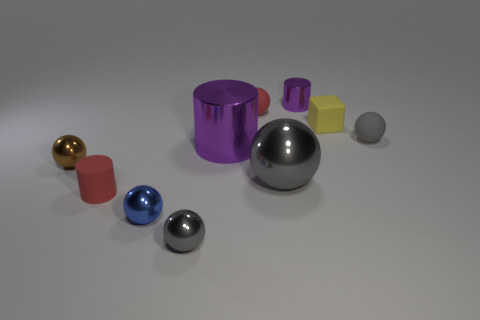There is a thing that is the same color as the tiny shiny cylinder; what is its size?
Your answer should be compact. Large. What is the shape of the rubber thing that is the same color as the large metal ball?
Offer a very short reply. Sphere. How many other large metal objects have the same shape as the big gray object?
Your answer should be very brief. 0. What number of purple things are the same size as the yellow matte cube?
Your response must be concise. 1. There is a red thing that is the same shape as the small purple shiny object; what is it made of?
Ensure brevity in your answer.  Rubber. What is the color of the rubber object that is in front of the brown shiny thing?
Your answer should be compact. Red. Is the number of objects that are in front of the yellow matte thing greater than the number of small purple cylinders?
Your answer should be compact. Yes. The matte block has what color?
Make the answer very short. Yellow. The purple object in front of the red ball that is on the right side of the small metal object that is on the left side of the blue ball is what shape?
Make the answer very short. Cylinder. What is the object that is on the right side of the brown shiny thing and on the left side of the blue ball made of?
Your answer should be compact. Rubber. 